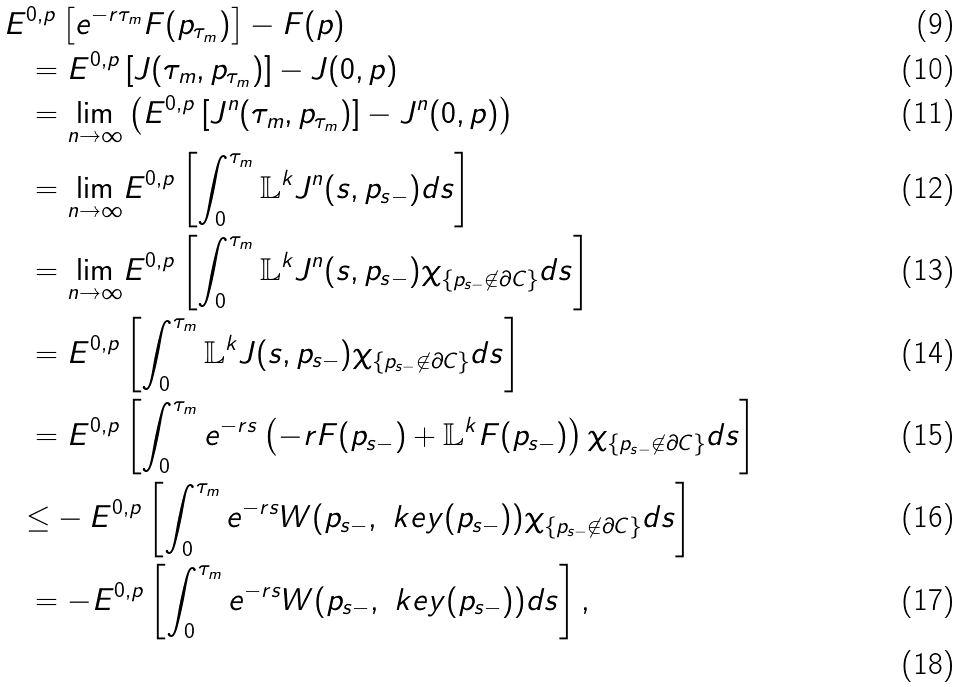Convert formula to latex. <formula><loc_0><loc_0><loc_500><loc_500>E & ^ { 0 , p } \left [ e ^ { - r \tau _ { m } } F ( p _ { \tau _ { m } } ) \right ] - F ( p ) \\ & = E ^ { 0 , p } \left [ J ( \tau _ { m } , p _ { \tau _ { m } } ) \right ] - J ( 0 , p ) \\ & = \underset { n \rightarrow \infty } { \lim } \left ( E ^ { 0 , p } \left [ J ^ { n } ( \tau _ { m } , p _ { \tau _ { m } } ) \right ] - J ^ { n } ( 0 , p ) \right ) \\ & = \underset { n \rightarrow \infty } { \lim } E ^ { 0 , p } \left [ \int _ { 0 } ^ { \tau _ { m } } \mathbb { L } ^ { k } J ^ { n } ( s , p _ { s - } ) d s \right ] \\ & = \underset { n \rightarrow \infty } { \lim } E ^ { 0 , p } \left [ \int _ { 0 } ^ { \tau _ { m } } \mathbb { L } ^ { k } J ^ { n } ( s , p _ { s - } ) \chi _ { \{ p _ { s - } \not \in \partial C \} } d s \right ] \\ & = E ^ { 0 , p } \left [ \int _ { 0 } ^ { \tau _ { m } } \mathbb { L } ^ { k } J ( s , p _ { s - } ) \chi _ { \{ p _ { s - } \not \in \partial C \} } d s \right ] \\ & = E ^ { 0 , p } \left [ \int _ { 0 } ^ { \tau _ { m } } { e ^ { - r s } \left ( - r F ( p _ { s - } ) + \mathbb { L } ^ { k } F ( p _ { s - } ) \right ) \chi _ { \{ p _ { s - } \not \in \partial C \} } d s } \right ] \\ & { \leq } - E ^ { 0 , p } \left [ \int _ { 0 } ^ { \tau _ { m } } e ^ { - r s } W ( p _ { s - } , \ k e y ( p _ { s - } ) ) \chi _ { \{ p _ { s - } \not \in \partial C \} } d s \right ] \\ & = - E ^ { 0 , p } \left [ \int _ { 0 } ^ { \tau _ { m } } e ^ { - r s } W ( p _ { s - } , \ k e y ( p _ { s - } ) ) d s \right ] , \\</formula> 